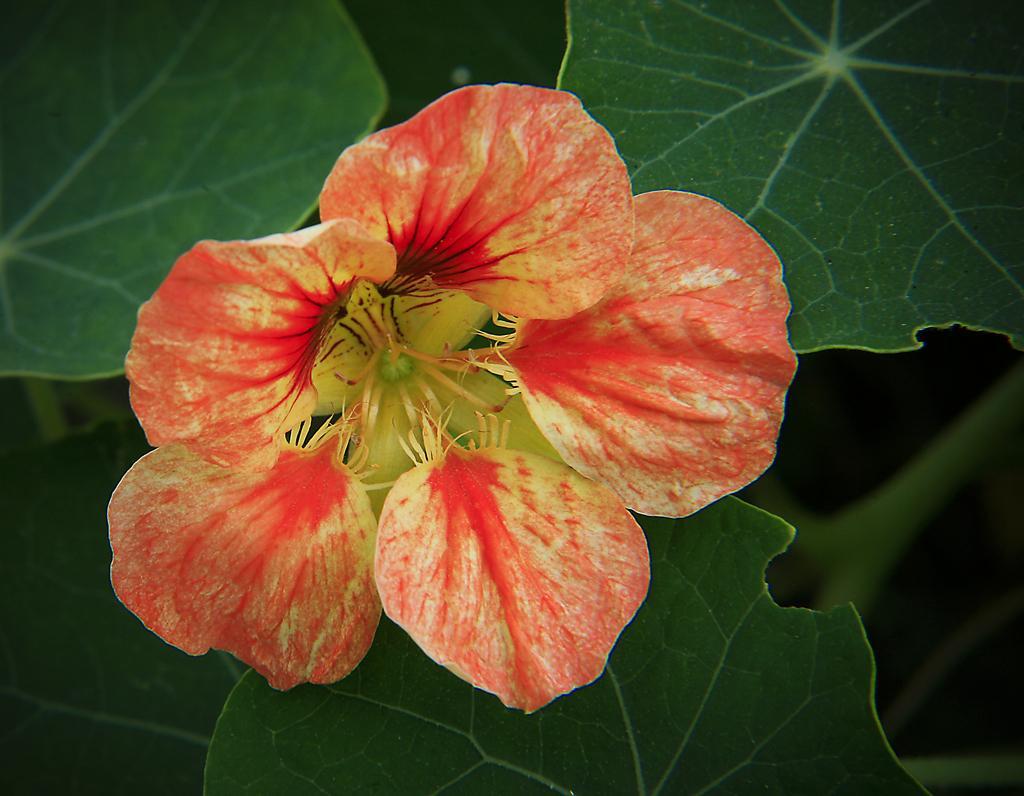Describe this image in one or two sentences. It is a beautiful flower, these are the leaves of a plant. 